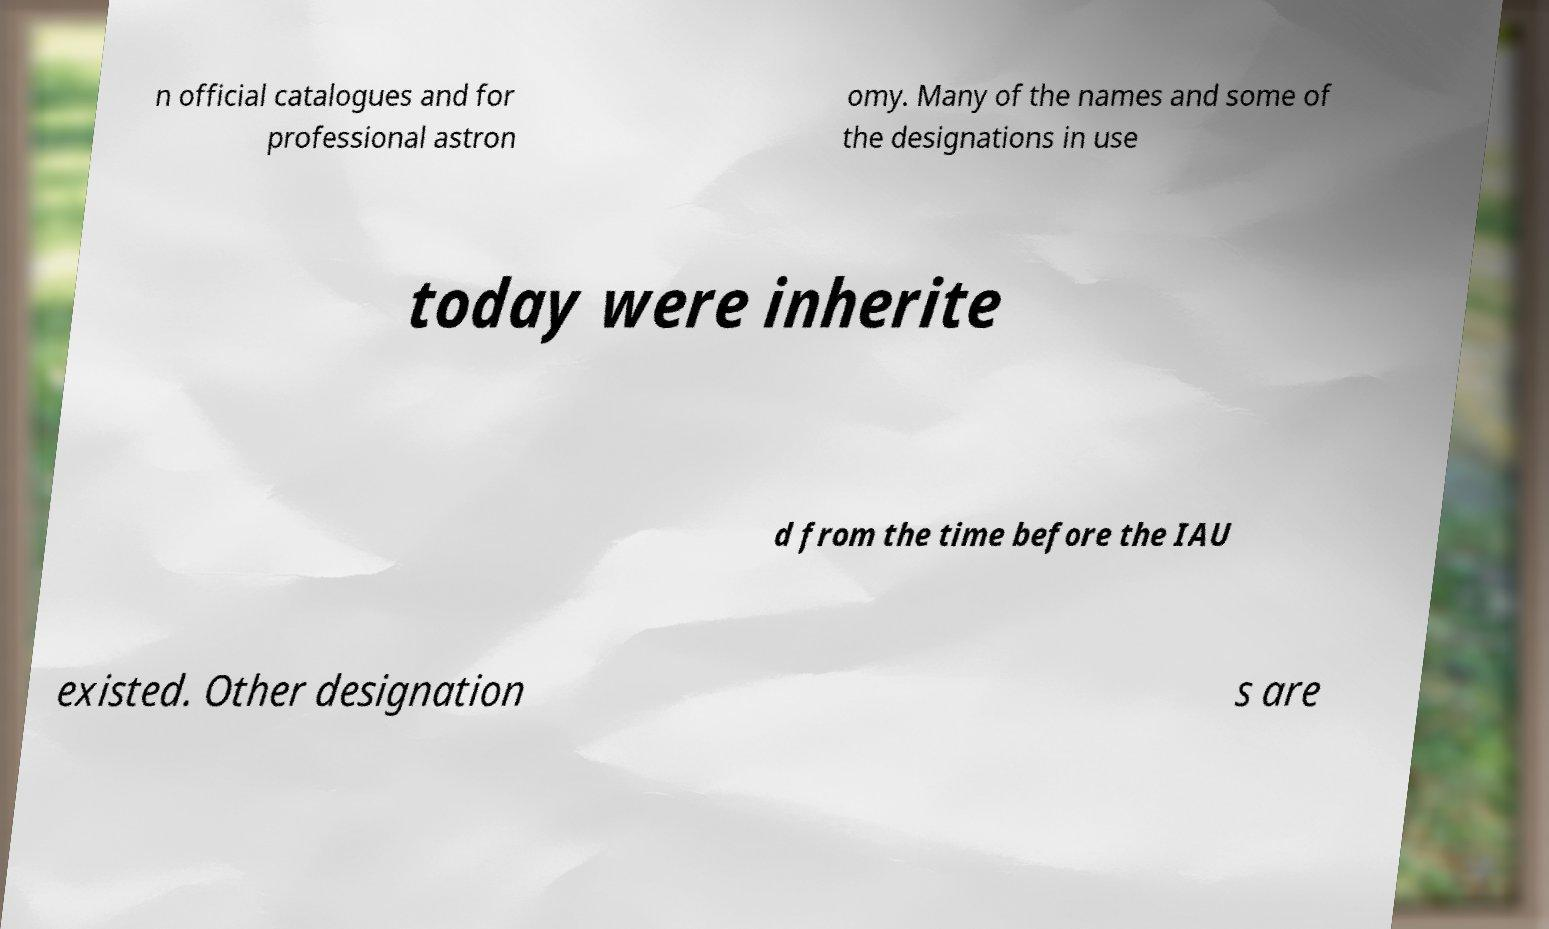Please identify and transcribe the text found in this image. n official catalogues and for professional astron omy. Many of the names and some of the designations in use today were inherite d from the time before the IAU existed. Other designation s are 